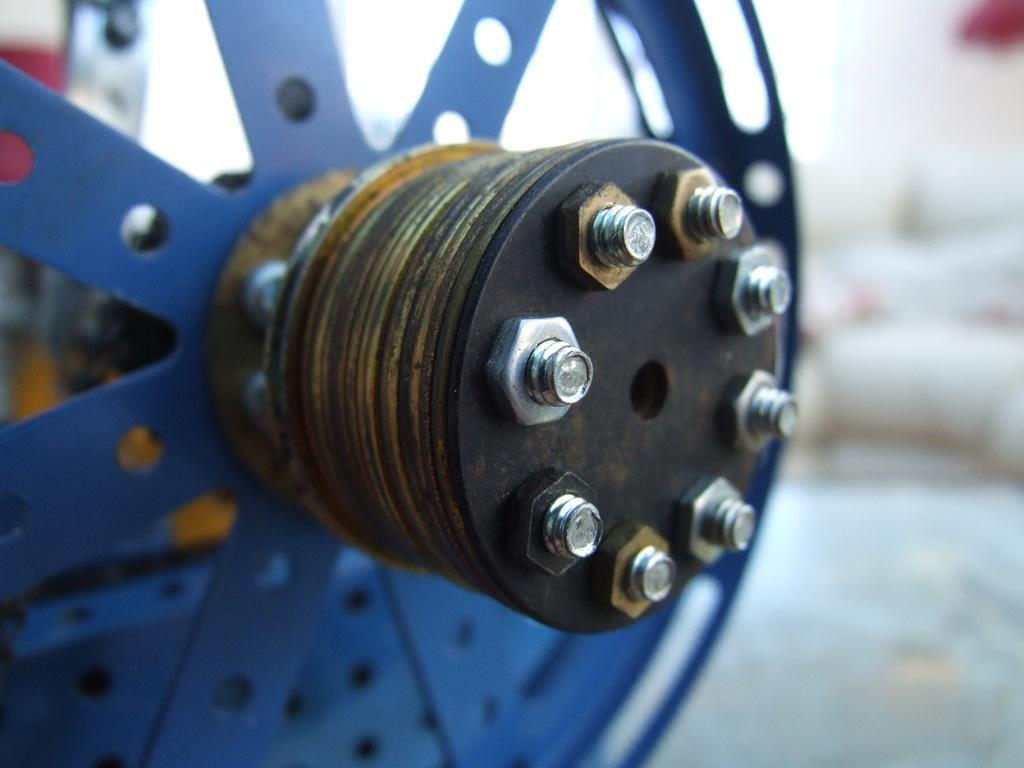What is the main object in the image? There is a blue color wheel in the image. What type of fasteners can be seen in the image? Bolts are visible in the image. Can you describe the background of the image? The background of the image is blurred. How many rabbits can be seen balancing on the color wheel in the image? There are no rabbits present in the image, and therefore no such activity can be observed. 